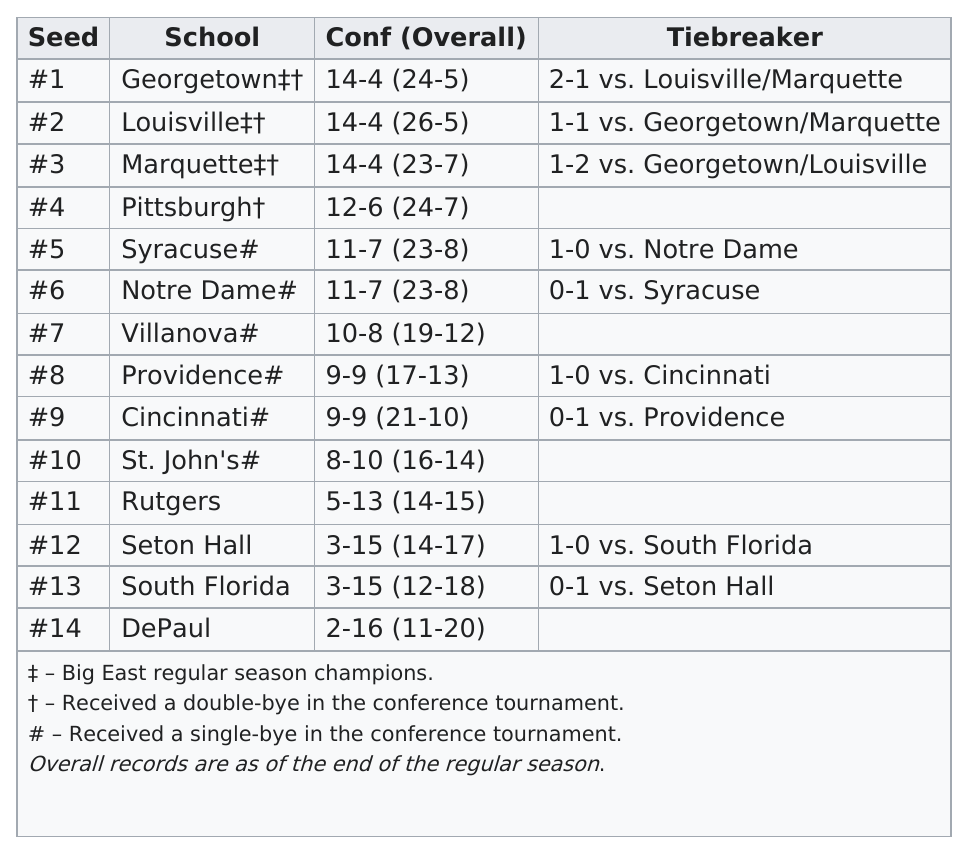Outline some significant characteristics in this image. Louisville had the most overall wins in school. DePaul was the team that finished in last place in this conference this season. Louisville had the most overall wins among all schools. Marquette is ranked four spots above Villanova in the number of seeds for the NCAA men's basketball tournament. The University of Syracuse and the University of Notre Dame had the same final conference record of 11-7 during the current season. 